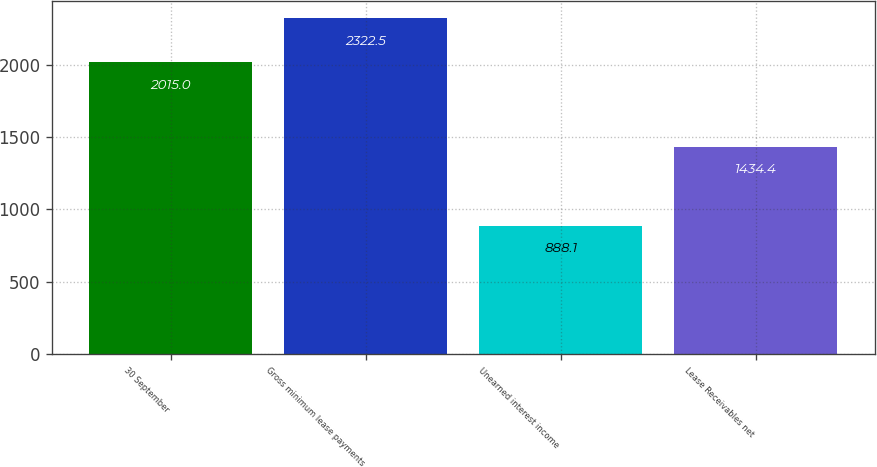<chart> <loc_0><loc_0><loc_500><loc_500><bar_chart><fcel>30 September<fcel>Gross minimum lease payments<fcel>Unearned interest income<fcel>Lease Receivables net<nl><fcel>2015<fcel>2322.5<fcel>888.1<fcel>1434.4<nl></chart> 